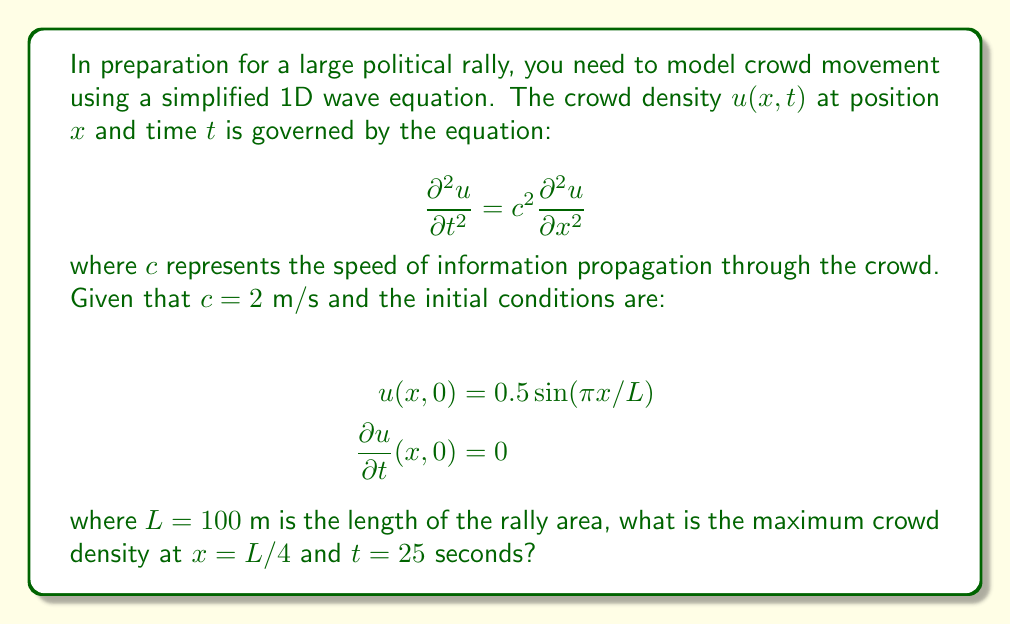What is the answer to this math problem? To solve this problem, we'll use the general solution for the 1D wave equation with the given initial conditions:

1) The general solution for the 1D wave equation is:

   $$u(x,t) = [f(x-ct) + g(x+ct)]/2$$

2) Given the initial conditions, we can determine that:

   $$f(x) = g(x) = 0.5 \sin(\pi x/L)$$

3) Substituting these into the general solution:

   $$u(x,t) = 0.25[\sin(\pi(x-ct)/L) + \sin(\pi(x+ct)/L)]$$

4) Using the trigonometric identity for the sum of sines:

   $$u(x,t) = 0.5 \sin(\pi x/L) \cos(\pi ct/L)$$

5) Now, we need to find the maximum value at $x = L/4$ and $t = 25$ seconds:

   $$u(L/4, 25) = 0.5 \sin(\pi/4) \cos(\pi \cdot 2 \cdot 25/100)$$

6) Simplifying:

   $$u(L/4, 25) = 0.5 \cdot \frac{\sqrt{2}}{2} \cdot \cos(\pi/2)$$

7) $\cos(\pi/2) = 0$, so the crowd density at this exact point and time is 0.

8) However, the question asks for the maximum density. The cosine function oscillates between -1 and 1, so the maximum value occurs when $\cos(\pi ct/L) = 1$:

   $$u_{max}(L/4, t) = 0.5 \sin(\pi/4) \cdot 1 = 0.5 \cdot \frac{\sqrt{2}}{2} \approx 0.3536$$
Answer: 0.3536 people/m 